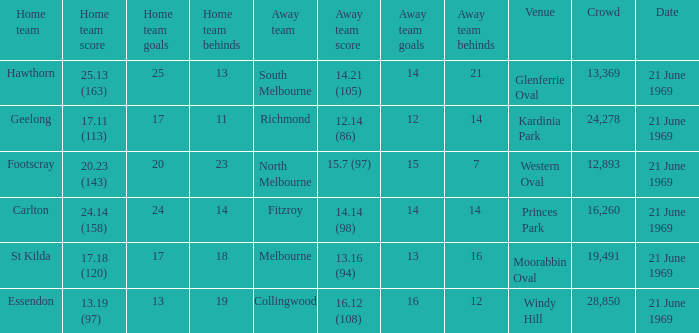What is Essendon's home team that has an away crowd size larger than 19,491? Collingwood. 